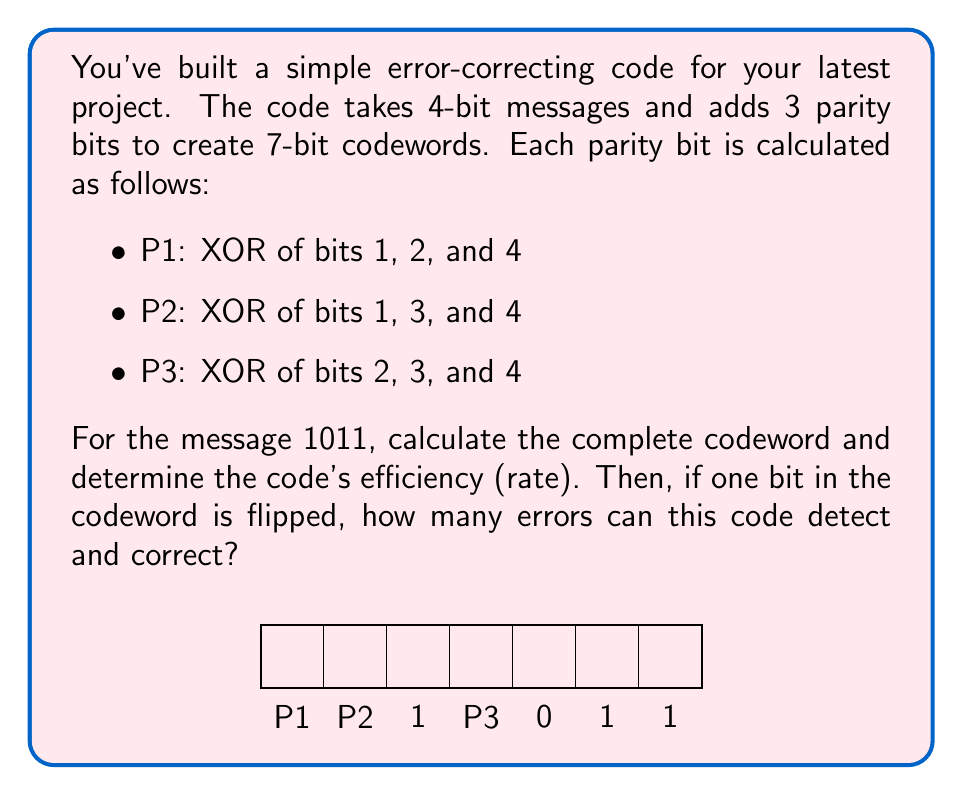Show me your answer to this math problem. Let's approach this step-by-step:

1) First, let's calculate the parity bits:
   P1 = 1 XOR 0 XOR 1 = 0
   P2 = 1 XOR 1 XOR 1 = 1
   P3 = 0 XOR 1 XOR 1 = 0

2) The complete codeword is therefore: 0110111

3) To calculate the code's efficiency (rate), we use the formula:
   $$\text{Rate} = \frac{\text{Number of information bits}}{\text{Total number of bits in codeword}}$$
   
   $$\text{Rate} = \frac{4}{7} \approx 0.571$$

4) This code can detect and correct single-bit errors. Here's why:
   - It can detect any single-bit error because the parity checks will fail.
   - It can correct any single-bit error because each bit contributes to a unique combination of parity bits, allowing us to identify which bit was flipped.

5) To see this, let's create a table of which bits contribute to which parity checks:
   P1: 1, 2, 4
   P2: 1, 3, 4
   P3: 2, 3, 4

   If any single bit is flipped, it will cause a unique pattern of parity check failures, allowing us to identify and correct the flipped bit.

6) However, this code cannot detect or correct 2 or more bit flips, as these could potentially result in a valid codeword or be mistaken for a different single-bit error.
Answer: Codeword: 0110111, Rate: 4/7 ≈ 0.571, Can detect and correct 1 error 